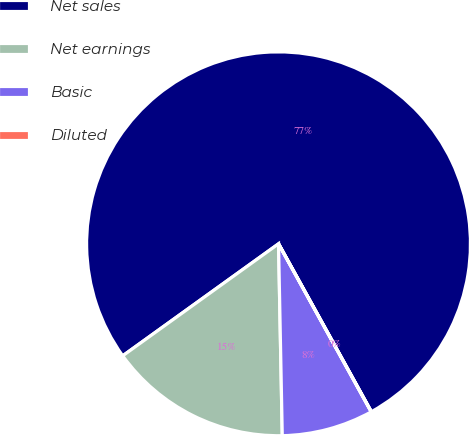Convert chart. <chart><loc_0><loc_0><loc_500><loc_500><pie_chart><fcel>Net sales<fcel>Net earnings<fcel>Basic<fcel>Diluted<nl><fcel>76.88%<fcel>15.39%<fcel>7.71%<fcel>0.02%<nl></chart> 